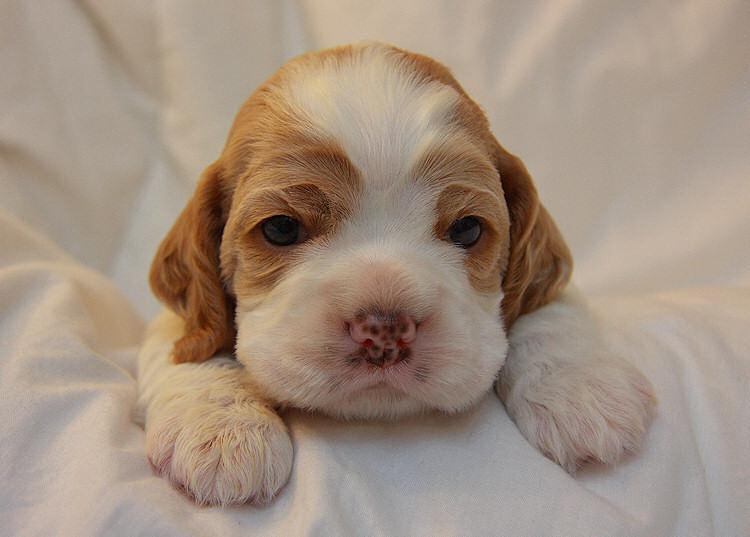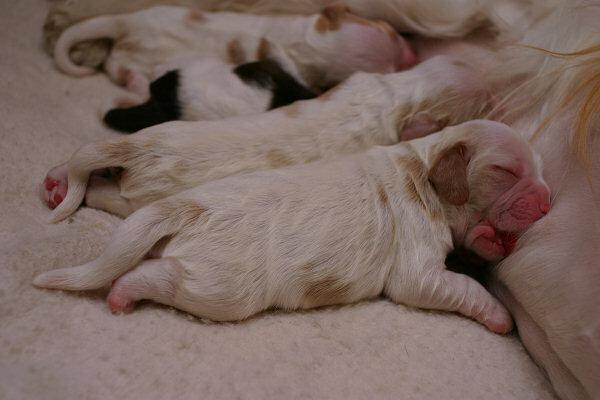The first image is the image on the left, the second image is the image on the right. For the images shown, is this caption "All of the pups are sleeping." true? Answer yes or no. No. The first image is the image on the left, the second image is the image on the right. Given the left and right images, does the statement "There are two dogs in the lefthand image." hold true? Answer yes or no. No. 